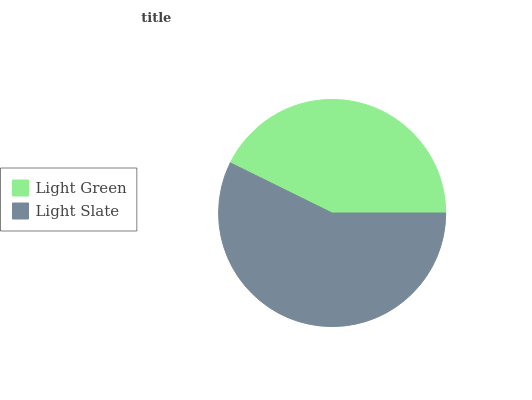Is Light Green the minimum?
Answer yes or no. Yes. Is Light Slate the maximum?
Answer yes or no. Yes. Is Light Slate the minimum?
Answer yes or no. No. Is Light Slate greater than Light Green?
Answer yes or no. Yes. Is Light Green less than Light Slate?
Answer yes or no. Yes. Is Light Green greater than Light Slate?
Answer yes or no. No. Is Light Slate less than Light Green?
Answer yes or no. No. Is Light Slate the high median?
Answer yes or no. Yes. Is Light Green the low median?
Answer yes or no. Yes. Is Light Green the high median?
Answer yes or no. No. Is Light Slate the low median?
Answer yes or no. No. 